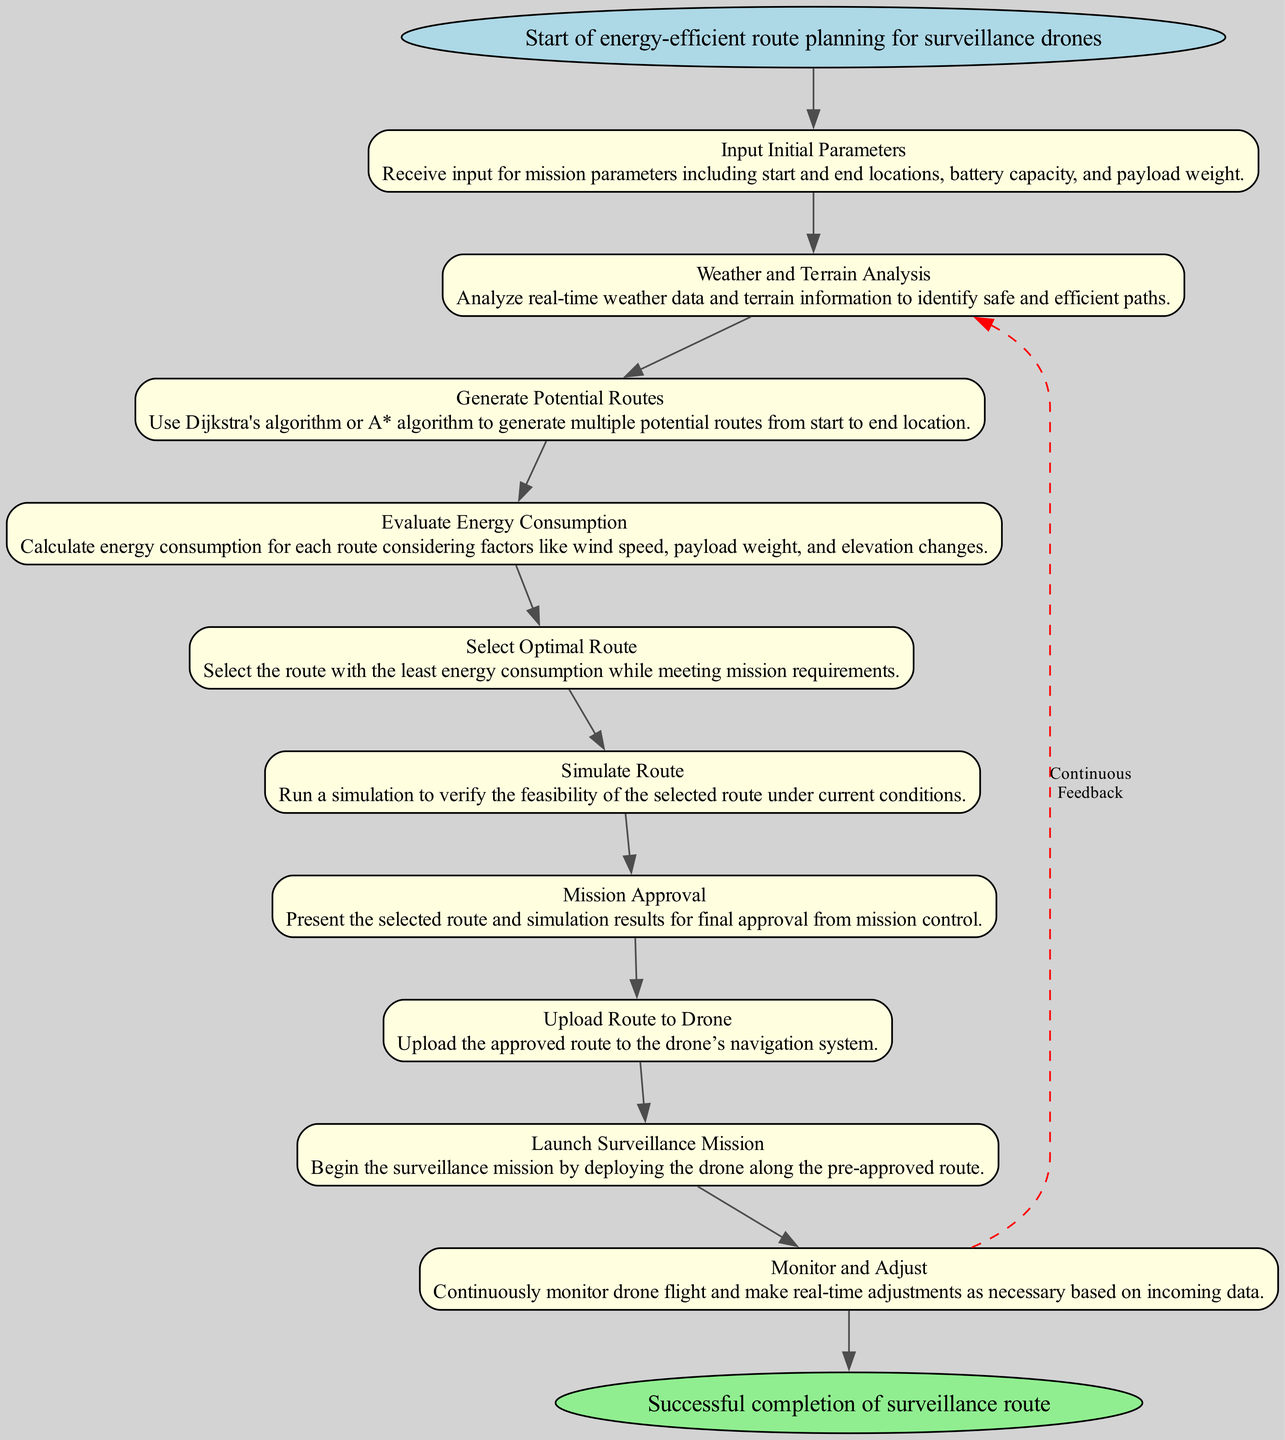What is the starting point of the flowchart? The starting point, labeled "Start," indicates the initiation of the energy-efficient route planning for surveillance drones, which is described at the top of the diagram.
Answer: Start of energy-efficient route planning for surveillance drones How many tasks are present in the flowchart? By counting the task nodes labeled from 1 to 10, we determine that there are ten tasks represented in the diagram.
Answer: 10 What is the final task before reaching the end? By following the task sequence, the last task in the flowchart is "Monitor and Adjust," which connects directly to the end node following all other tasks.
Answer: Monitor and Adjust What is the purpose of the "Evaluate Energy Consumption" task? This task calculates energy consumption for each route by taking into account wind speed, payload weight, and elevation changes, which is key for choosing the optimal path.
Answer: Calculate energy consumption Which task receives a feedback loop? The "Monitor and Adjust" task is linked back to "Weather and Terrain Analysis" through a dashed edge, indicating continuous feedback and adjustments based on real-time data.
Answer: Weather and Terrain Analysis What selection method is used in the "Select Optimal Route" task? The flowchart suggests selecting the route with the least energy consumption, which implies an optimization process is at play in this task.
Answer: Least energy consumption What action occurs immediately after "Mission Approval"? Following the "Mission Approval," the immediate action is to "Upload Route to Drone," where the agreed-upon route is transferred to the drone's navigation system.
Answer: Upload Route to Drone What kind of analysis is performed initially in the flowchart? The initial analysis involves "Weather and Terrain Analysis," as this step is crucial for determining safe and efficient path options before generating routes.
Answer: Weather and Terrain Analysis How many edges connect the tasks in the flowchart? The flowchart has ten tasks, and each task connects to the next with an edge. Thus, there will be nine edges connecting the tasks, plus two additional edges connecting start and end nodes.
Answer: 11 